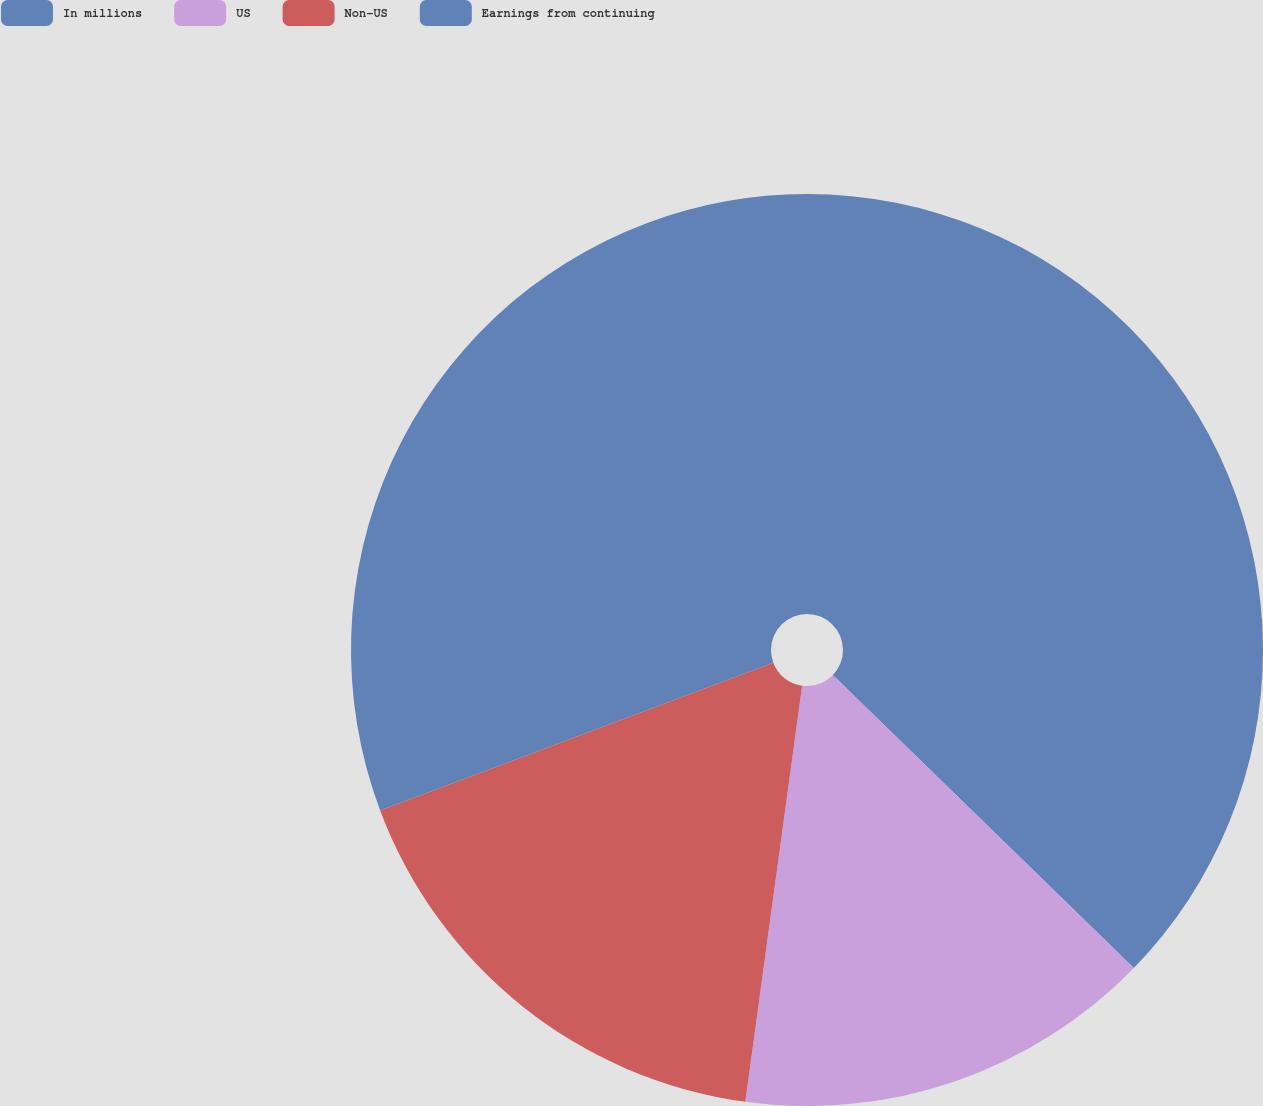<chart> <loc_0><loc_0><loc_500><loc_500><pie_chart><fcel>In millions<fcel>US<fcel>Non-US<fcel>Earnings from continuing<nl><fcel>37.28%<fcel>14.88%<fcel>17.12%<fcel>30.72%<nl></chart> 